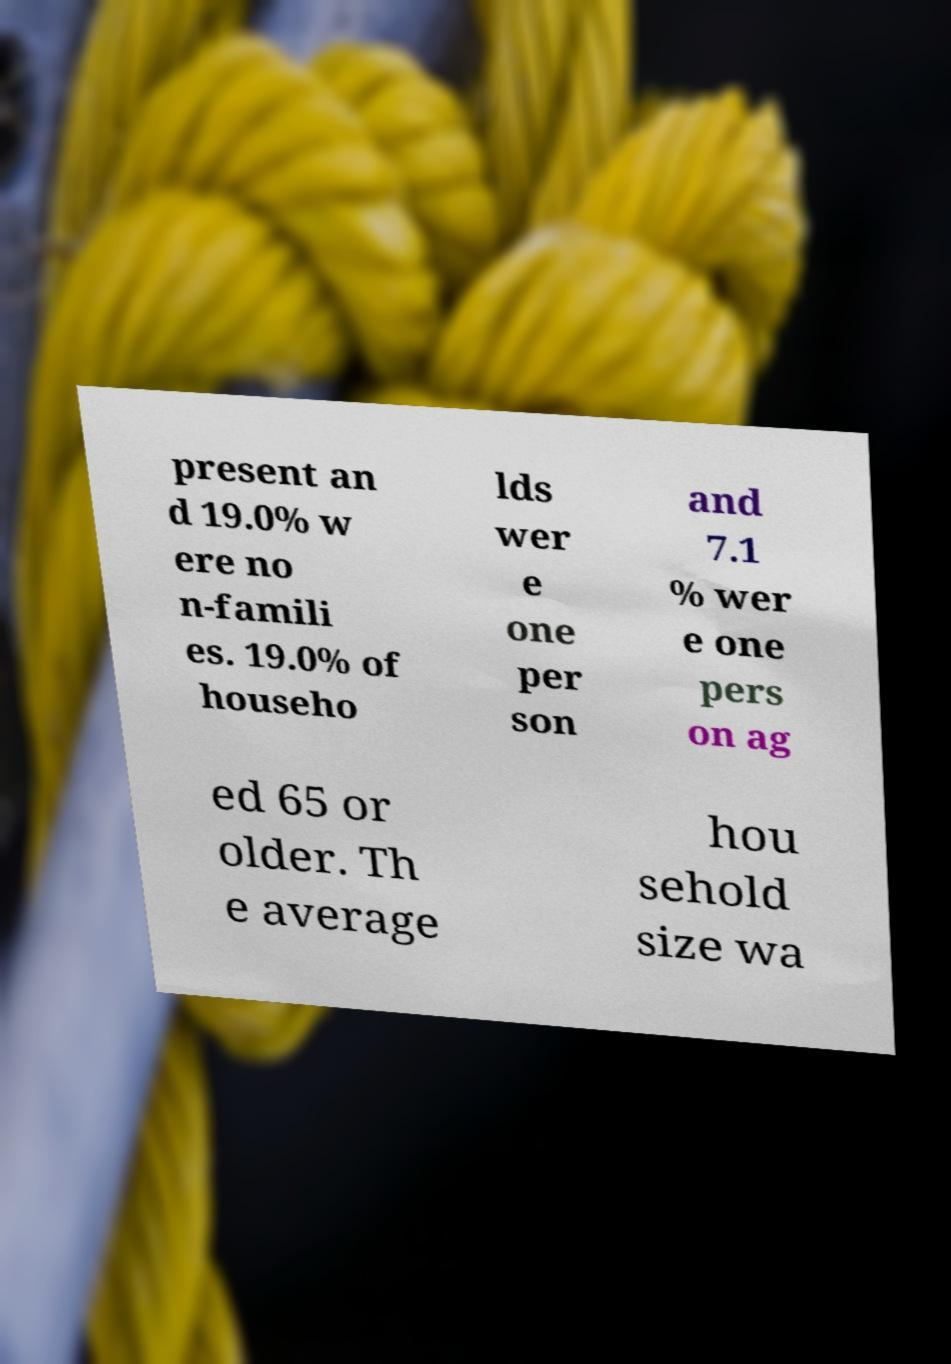Please identify and transcribe the text found in this image. present an d 19.0% w ere no n-famili es. 19.0% of househo lds wer e one per son and 7.1 % wer e one pers on ag ed 65 or older. Th e average hou sehold size wa 